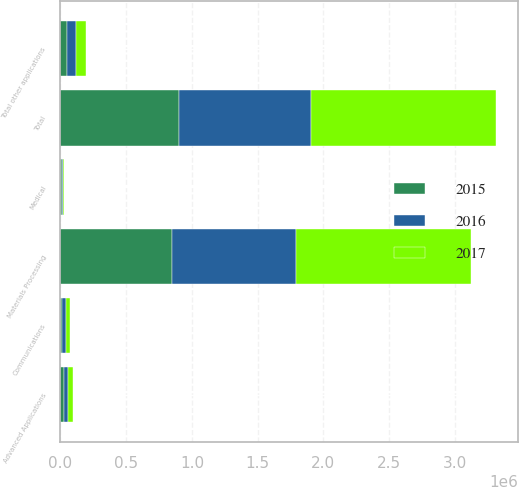Convert chart. <chart><loc_0><loc_0><loc_500><loc_500><stacked_bar_chart><ecel><fcel>Materials Processing<fcel>Advanced Applications<fcel>Communications<fcel>Medical<fcel>Total other applications<fcel>Total<nl><fcel>2017<fcel>1.33261e+06<fcel>36836<fcel>32023<fcel>7423<fcel>76282<fcel>1.40889e+06<nl><fcel>2016<fcel>942119<fcel>28166<fcel>28823<fcel>7065<fcel>64054<fcel>1.00617e+06<nl><fcel>2015<fcel>849335<fcel>28866<fcel>14399<fcel>8665<fcel>51930<fcel>901265<nl></chart> 